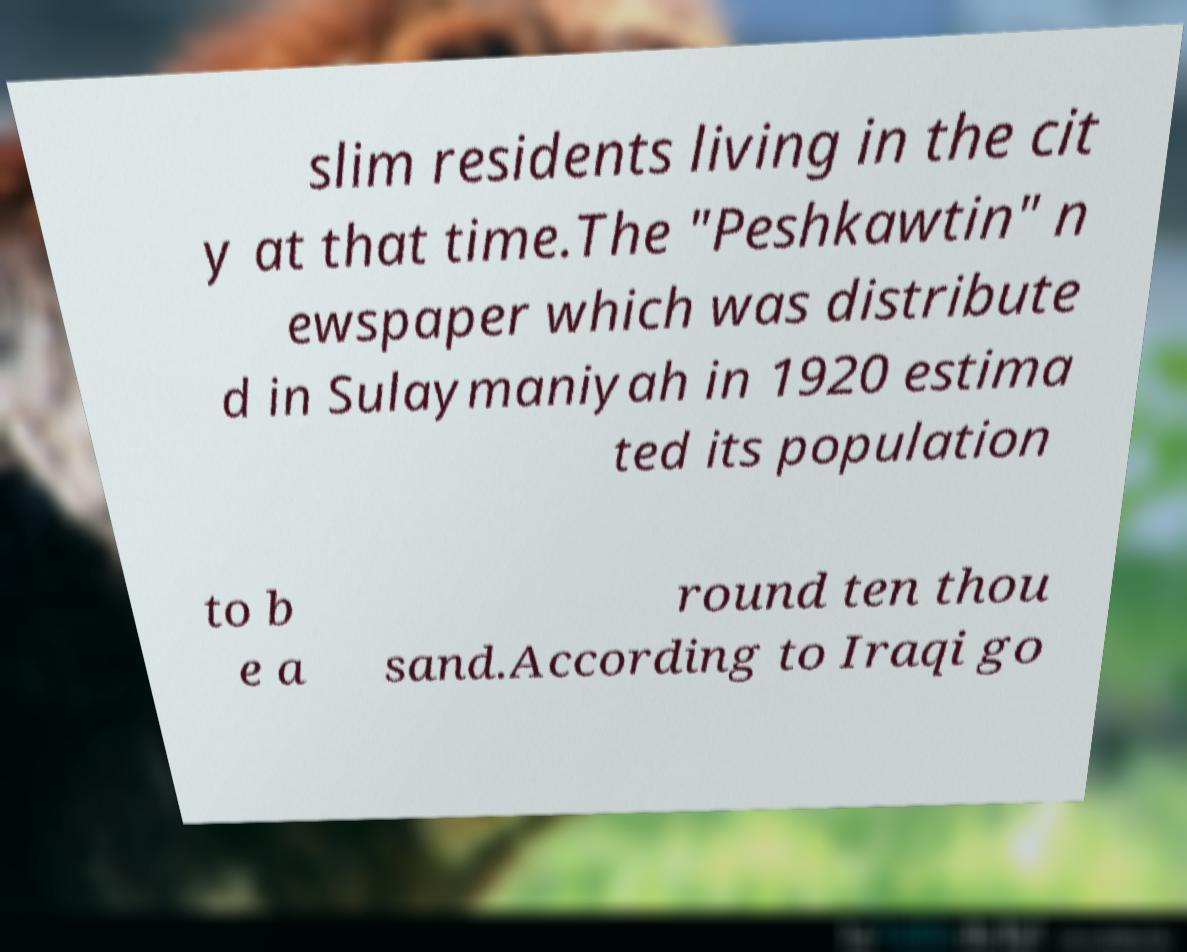Please read and relay the text visible in this image. What does it say? slim residents living in the cit y at that time.The "Peshkawtin" n ewspaper which was distribute d in Sulaymaniyah in 1920 estima ted its population to b e a round ten thou sand.According to Iraqi go 